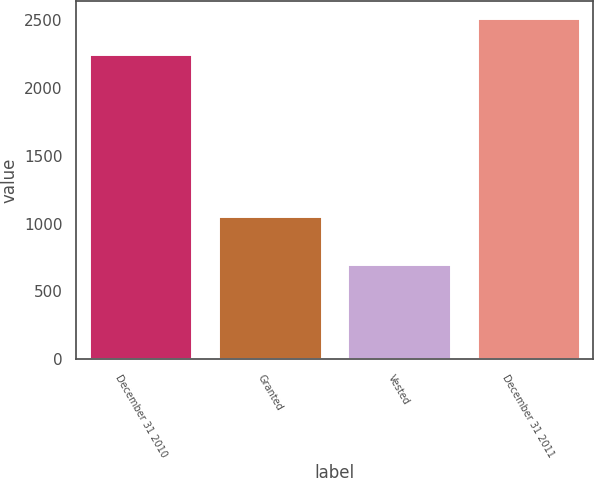Convert chart to OTSL. <chart><loc_0><loc_0><loc_500><loc_500><bar_chart><fcel>December 31 2010<fcel>Granted<fcel>Vested<fcel>December 31 2011<nl><fcel>2250<fcel>1059<fcel>706<fcel>2512<nl></chart> 